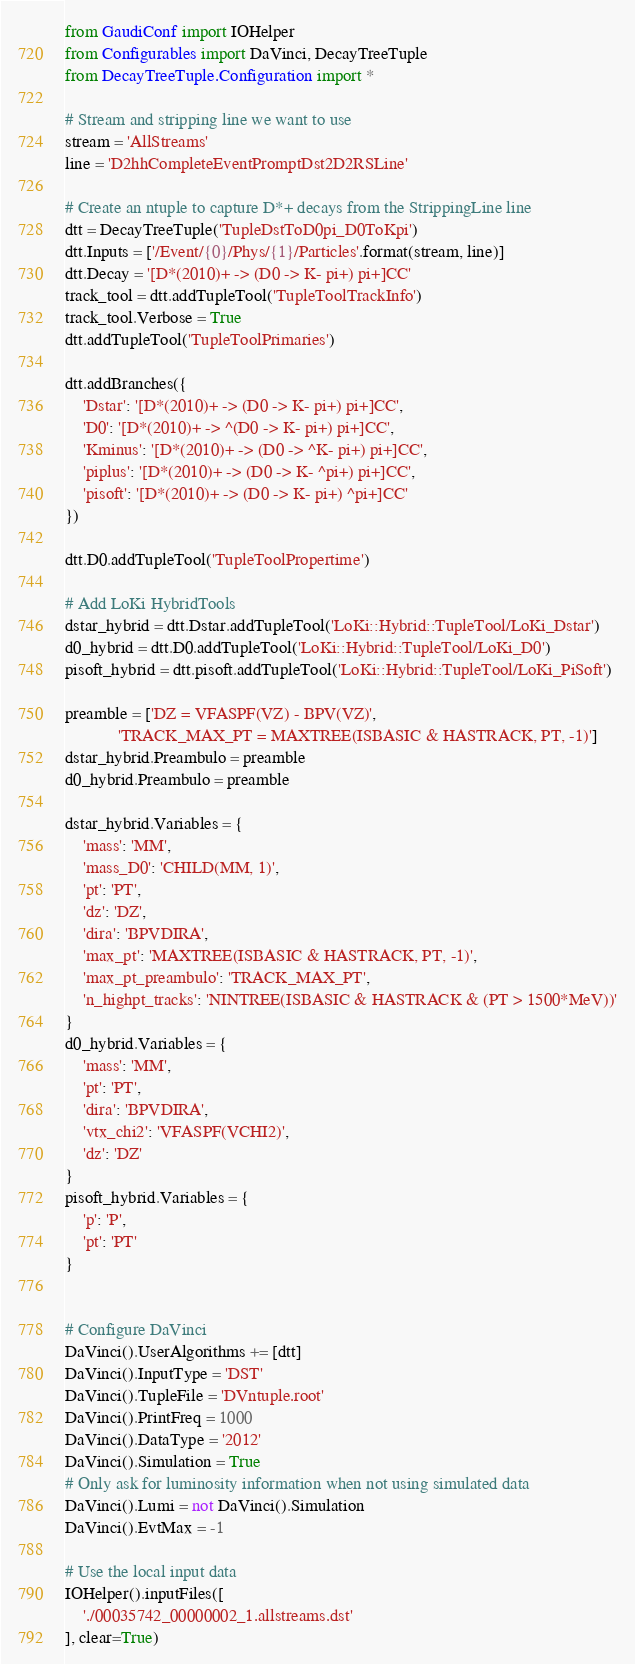<code> <loc_0><loc_0><loc_500><loc_500><_Python_>from GaudiConf import IOHelper
from Configurables import DaVinci, DecayTreeTuple
from DecayTreeTuple.Configuration import *

# Stream and stripping line we want to use
stream = 'AllStreams'
line = 'D2hhCompleteEventPromptDst2D2RSLine'

# Create an ntuple to capture D*+ decays from the StrippingLine line
dtt = DecayTreeTuple('TupleDstToD0pi_D0ToKpi')
dtt.Inputs = ['/Event/{0}/Phys/{1}/Particles'.format(stream, line)]
dtt.Decay = '[D*(2010)+ -> (D0 -> K- pi+) pi+]CC'
track_tool = dtt.addTupleTool('TupleToolTrackInfo')
track_tool.Verbose = True
dtt.addTupleTool('TupleToolPrimaries')

dtt.addBranches({
    'Dstar': '[D*(2010)+ -> (D0 -> K- pi+) pi+]CC',
    'D0': '[D*(2010)+ -> ^(D0 -> K- pi+) pi+]CC',
    'Kminus': '[D*(2010)+ -> (D0 -> ^K- pi+) pi+]CC',
    'piplus': '[D*(2010)+ -> (D0 -> K- ^pi+) pi+]CC',
    'pisoft': '[D*(2010)+ -> (D0 -> K- pi+) ^pi+]CC'
})

dtt.D0.addTupleTool('TupleToolPropertime')

# Add LoKi HybridTools
dstar_hybrid = dtt.Dstar.addTupleTool('LoKi::Hybrid::TupleTool/LoKi_Dstar')
d0_hybrid = dtt.D0.addTupleTool('LoKi::Hybrid::TupleTool/LoKi_D0')
pisoft_hybrid = dtt.pisoft.addTupleTool('LoKi::Hybrid::TupleTool/LoKi_PiSoft')

preamble = ['DZ = VFASPF(VZ) - BPV(VZ)',
            'TRACK_MAX_PT = MAXTREE(ISBASIC & HASTRACK, PT, -1)']
dstar_hybrid.Preambulo = preamble
d0_hybrid.Preambulo = preamble

dstar_hybrid.Variables = {
    'mass': 'MM',
    'mass_D0': 'CHILD(MM, 1)',
    'pt': 'PT',
    'dz': 'DZ',
    'dira': 'BPVDIRA',
    'max_pt': 'MAXTREE(ISBASIC & HASTRACK, PT, -1)',
    'max_pt_preambulo': 'TRACK_MAX_PT',
    'n_highpt_tracks': 'NINTREE(ISBASIC & HASTRACK & (PT > 1500*MeV))'
}
d0_hybrid.Variables = {
    'mass': 'MM',
    'pt': 'PT',
    'dira': 'BPVDIRA',
    'vtx_chi2': 'VFASPF(VCHI2)',
    'dz': 'DZ'
}
pisoft_hybrid.Variables = {
    'p': 'P',
    'pt': 'PT'
}


# Configure DaVinci
DaVinci().UserAlgorithms += [dtt]
DaVinci().InputType = 'DST'
DaVinci().TupleFile = 'DVntuple.root'
DaVinci().PrintFreq = 1000
DaVinci().DataType = '2012'
DaVinci().Simulation = True
# Only ask for luminosity information when not using simulated data
DaVinci().Lumi = not DaVinci().Simulation
DaVinci().EvtMax = -1

# Use the local input data
IOHelper().inputFiles([
    './00035742_00000002_1.allstreams.dst'
], clear=True)
</code> 